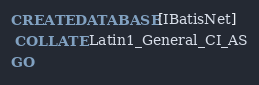Convert code to text. <code><loc_0><loc_0><loc_500><loc_500><_SQL_>
CREATE DATABASE [IBatisNet] 
 COLLATE Latin1_General_CI_AS
GO

</code> 